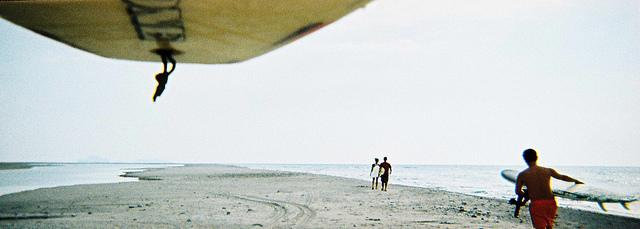How will the people here likely propel themselves upon waves? Please explain your reasoning. surfing. They have boards used to ride waves 